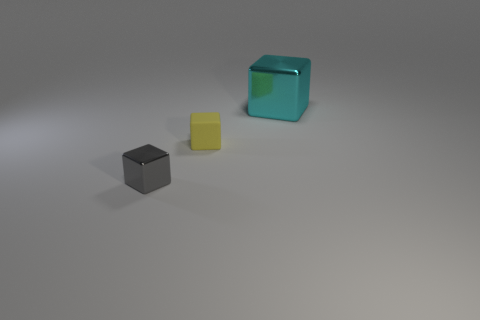What number of cyan cubes are there?
Your response must be concise. 1. What shape is the small thing on the left side of the tiny yellow object?
Offer a very short reply. Cube. The shiny block right of the metal object that is in front of the metallic object that is behind the gray metallic block is what color?
Give a very brief answer. Cyan. What is the shape of the cyan thing that is made of the same material as the tiny gray object?
Provide a succinct answer. Cube. Are there fewer small green spheres than large blocks?
Keep it short and to the point. Yes. Is the material of the large cube the same as the yellow cube?
Offer a terse response. No. What number of other things are the same color as the tiny matte object?
Offer a terse response. 0. Is the number of red metallic things greater than the number of yellow cubes?
Provide a short and direct response. No. There is a gray block; is it the same size as the thing that is to the right of the small yellow object?
Keep it short and to the point. No. What is the color of the shiny object in front of the big cyan thing?
Keep it short and to the point. Gray. 